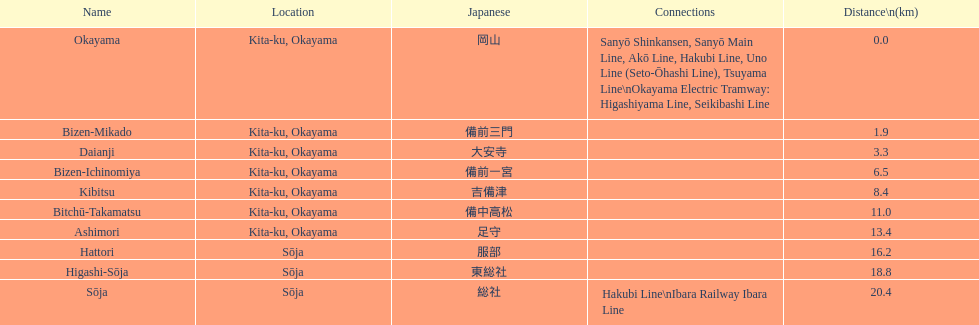Can you list the stations that serve as transfer points between lines? Okayama, Sōja. 